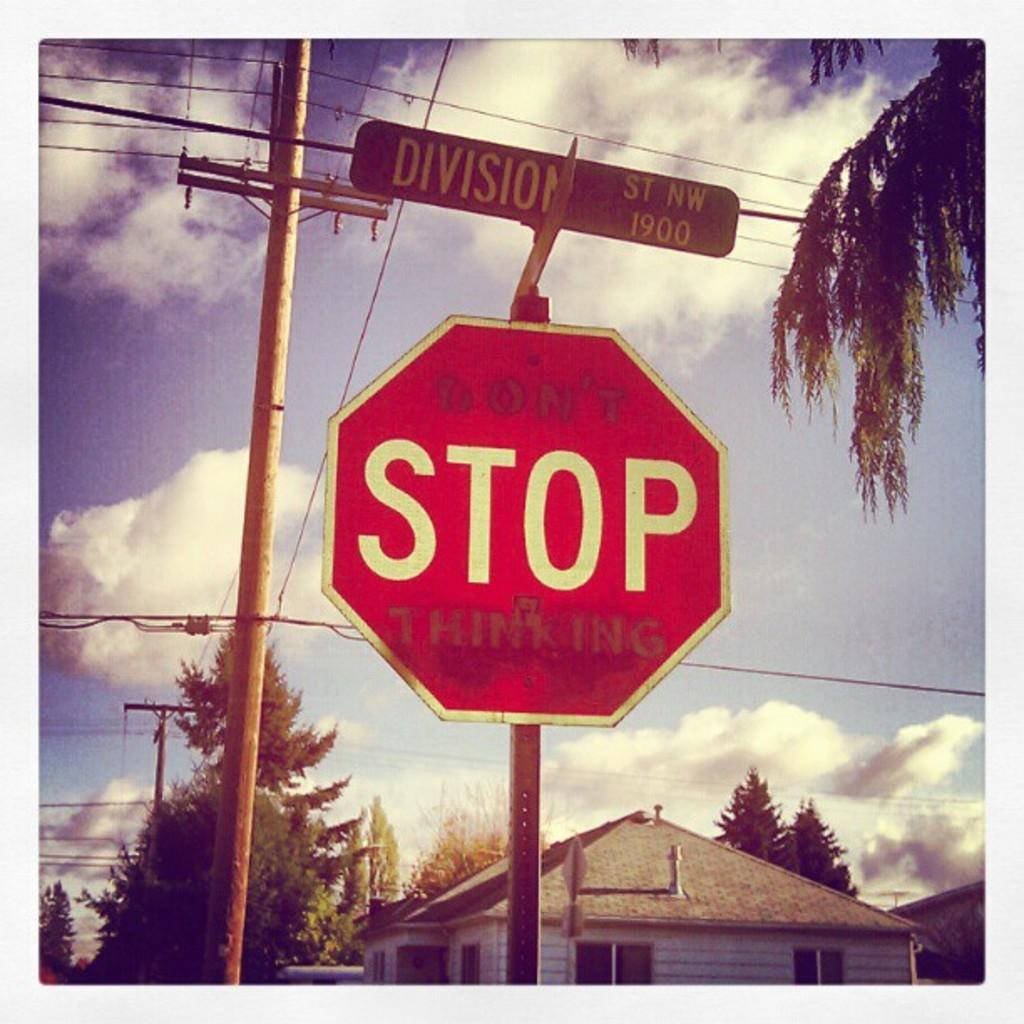<image>
Render a clear and concise summary of the photo. A stop sign covered in graffitti that says "Don't stop thinking." 